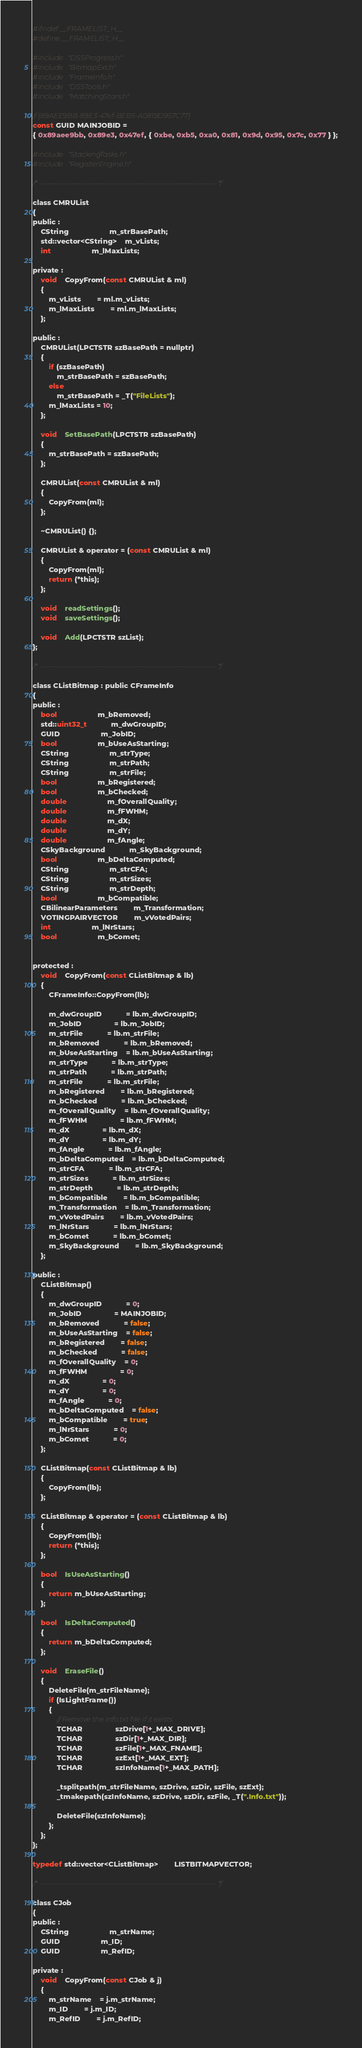<code> <loc_0><loc_0><loc_500><loc_500><_C_>#ifndef __FRAMELIST_H__
#define __FRAMELIST_H__

#include "DSSProgress.h"
#include "BitmapExt.h"
#include "FrameInfo.h"
#include "DSSTools.h"
#include "MatchingStars.h"

// {89AEE9BB-89E3-47ef-BEB5-A0819D957C77}
const GUID MAINJOBID =
{ 0x89aee9bb, 0x89e3, 0x47ef, { 0xbe, 0xb5, 0xa0, 0x81, 0x9d, 0x95, 0x7c, 0x77 } };

#include "StackingTasks.h"
#include "RegisterEngine.h"

/* ------------------------------------------------------------------- */

class CMRUList
{
public :
	CString					m_strBasePath;
	std::vector<CString>	m_vLists;
	int					m_lMaxLists;

private :
	void	CopyFrom(const CMRUList & ml)
	{
		m_vLists		= ml.m_vLists;
		m_lMaxLists		= ml.m_lMaxLists;
	};

public :
	CMRUList(LPCTSTR szBasePath = nullptr)
	{
		if (szBasePath)
			m_strBasePath = szBasePath;
		else
			m_strBasePath = _T("FileLists");
		m_lMaxLists = 10;
	};

	void	SetBasePath(LPCTSTR szBasePath)
	{
		m_strBasePath = szBasePath;
	};

	CMRUList(const CMRUList & ml)
	{
		CopyFrom(ml);
	};

	~CMRUList() {};

	CMRUList & operator = (const CMRUList & ml)
	{
		CopyFrom(ml);
		return (*this);
	};

	void	readSettings();
	void	saveSettings();

	void	Add(LPCTSTR szList);
};

/* ------------------------------------------------------------------- */

class CListBitmap : public CFrameInfo
{
public :
	bool					m_bRemoved;
	std::uint32_t			m_dwGroupID;
	GUID					m_JobID;
	bool					m_bUseAsStarting;
	CString					m_strType;
	CString					m_strPath;
	CString					m_strFile;
	bool					m_bRegistered;
	bool					m_bChecked;
	double					m_fOverallQuality;
	double					m_fFWHM;
	double					m_dX;
	double					m_dY;
	double					m_fAngle;
	CSkyBackground			m_SkyBackground;
	bool					m_bDeltaComputed;
	CString					m_strCFA;
	CString					m_strSizes;
	CString					m_strDepth;
	bool					m_bCompatible;
	CBilinearParameters		m_Transformation;
	VOTINGPAIRVECTOR		m_vVotedPairs;
	int					m_lNrStars;
	bool					m_bComet;


protected :
	void	CopyFrom(const CListBitmap & lb)
	{
		CFrameInfo::CopyFrom(lb);

		m_dwGroupID			= lb.m_dwGroupID;
		m_JobID				= lb.m_JobID;
		m_strFile			= lb.m_strFile;
		m_bRemoved			= lb.m_bRemoved;
		m_bUseAsStarting	= lb.m_bUseAsStarting;
		m_strType			= lb.m_strType;
		m_strPath			= lb.m_strPath;
		m_strFile			= lb.m_strFile;
		m_bRegistered		= lb.m_bRegistered;
		m_bChecked			= lb.m_bChecked;
		m_fOverallQuality	= lb.m_fOverallQuality;
		m_fFWHM				= lb.m_fFWHM;
		m_dX				= lb.m_dX;
		m_dY				= lb.m_dY;
		m_fAngle			= lb.m_fAngle;
		m_bDeltaComputed	= lb.m_bDeltaComputed;
		m_strCFA			= lb.m_strCFA;
		m_strSizes			= lb.m_strSizes;
		m_strDepth			= lb.m_strDepth;
		m_bCompatible		= lb.m_bCompatible;
		m_Transformation	= lb.m_Transformation;
		m_vVotedPairs		= lb.m_vVotedPairs;
		m_lNrStars			= lb.m_lNrStars;
		m_bComet			= lb.m_bComet;
		m_SkyBackground		= lb.m_SkyBackground;
	};

public :
	CListBitmap()
	{
		m_dwGroupID			= 0;
		m_JobID				= MAINJOBID;
		m_bRemoved			= false;
		m_bUseAsStarting	= false;
		m_bRegistered		= false;
		m_bChecked			= false;
		m_fOverallQuality	= 0;
		m_fFWHM				= 0;
		m_dX				= 0;
		m_dY				= 0;
		m_fAngle			= 0;
		m_bDeltaComputed	= false;
		m_bCompatible		= true;
		m_lNrStars			= 0;
		m_bComet			= 0;
	};

	CListBitmap(const CListBitmap & lb)
	{
		CopyFrom(lb);
	};

	CListBitmap & operator = (const CListBitmap & lb)
	{
		CopyFrom(lb);
		return (*this);
	};

	bool	IsUseAsStarting()
	{
		return m_bUseAsStarting;
	};

	bool	IsDeltaComputed()
	{
		return m_bDeltaComputed;
	};

	void	EraseFile()
	{
		DeleteFile(m_strFileName);
		if (IsLightFrame())
		{
			// Remove the Info.txt file if it exists
			TCHAR				szDrive[1+_MAX_DRIVE];
			TCHAR				szDir[1+_MAX_DIR];
			TCHAR				szFile[1+_MAX_FNAME];
			TCHAR				szExt[1+_MAX_EXT];
			TCHAR				szInfoName[1+_MAX_PATH];

			_tsplitpath(m_strFileName, szDrive, szDir, szFile, szExt);
			_tmakepath(szInfoName, szDrive, szDir, szFile, _T(".Info.txt"));

			DeleteFile(szInfoName);
		};
	};
};

typedef std::vector<CListBitmap>		LISTBITMAPVECTOR;

/* ------------------------------------------------------------------- */

class CJob
{
public :
	CString					m_strName;
	GUID					m_ID;
	GUID					m_RefID;

private :
	void	CopyFrom(const CJob & j)
	{
		m_strName	= j.m_strName;
		m_ID		= j.m_ID;
		m_RefID		= j.m_RefID;</code> 